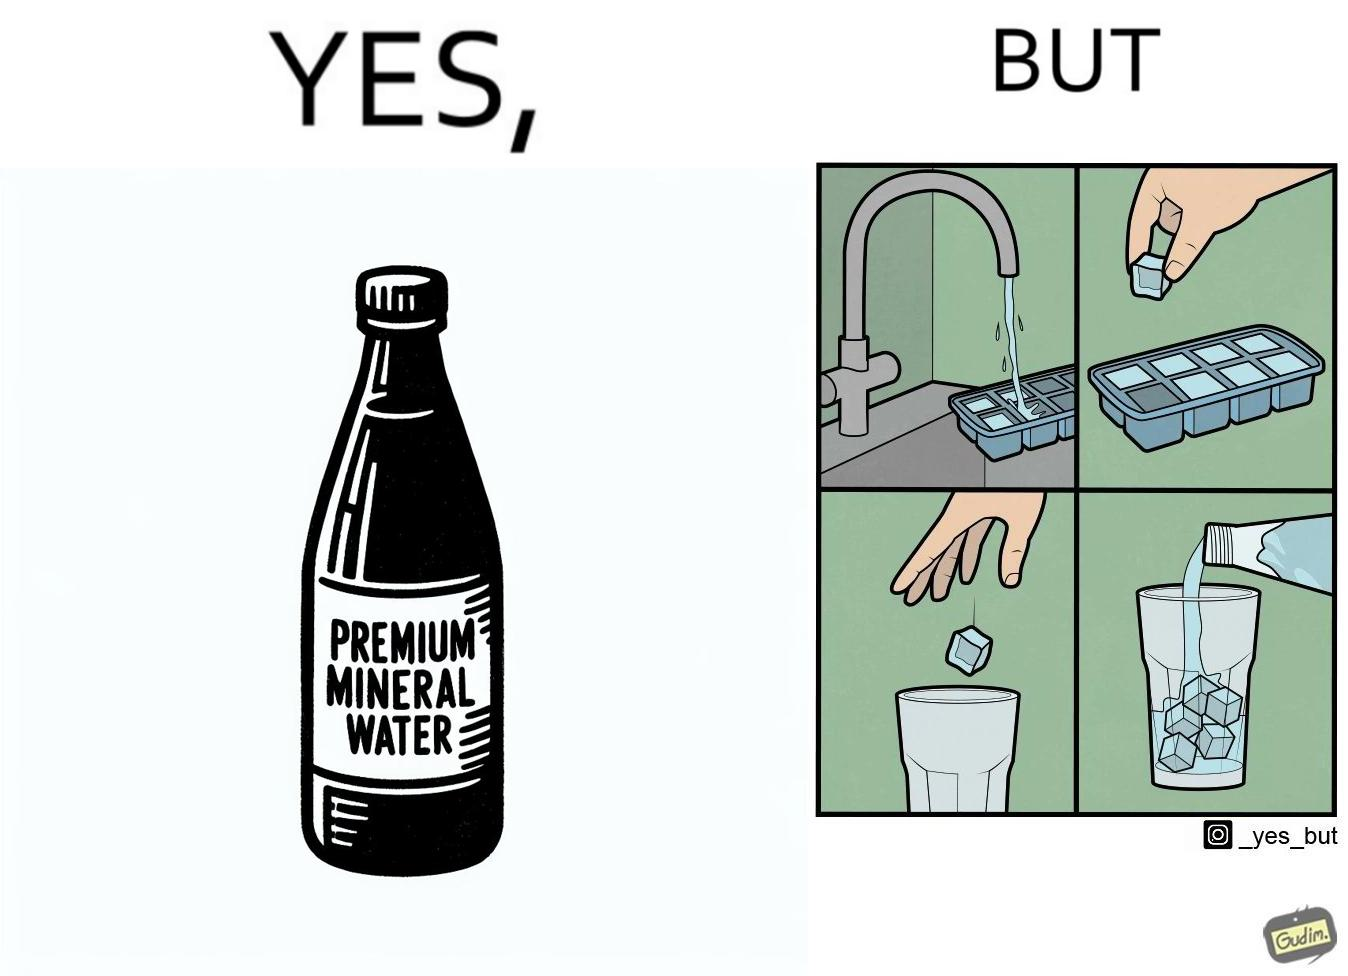Explain why this image is satirical. This image is ironical, as a bottle of mineral water is being used along with ice cubes from tap water, while the sama tap water could have been instead used. 